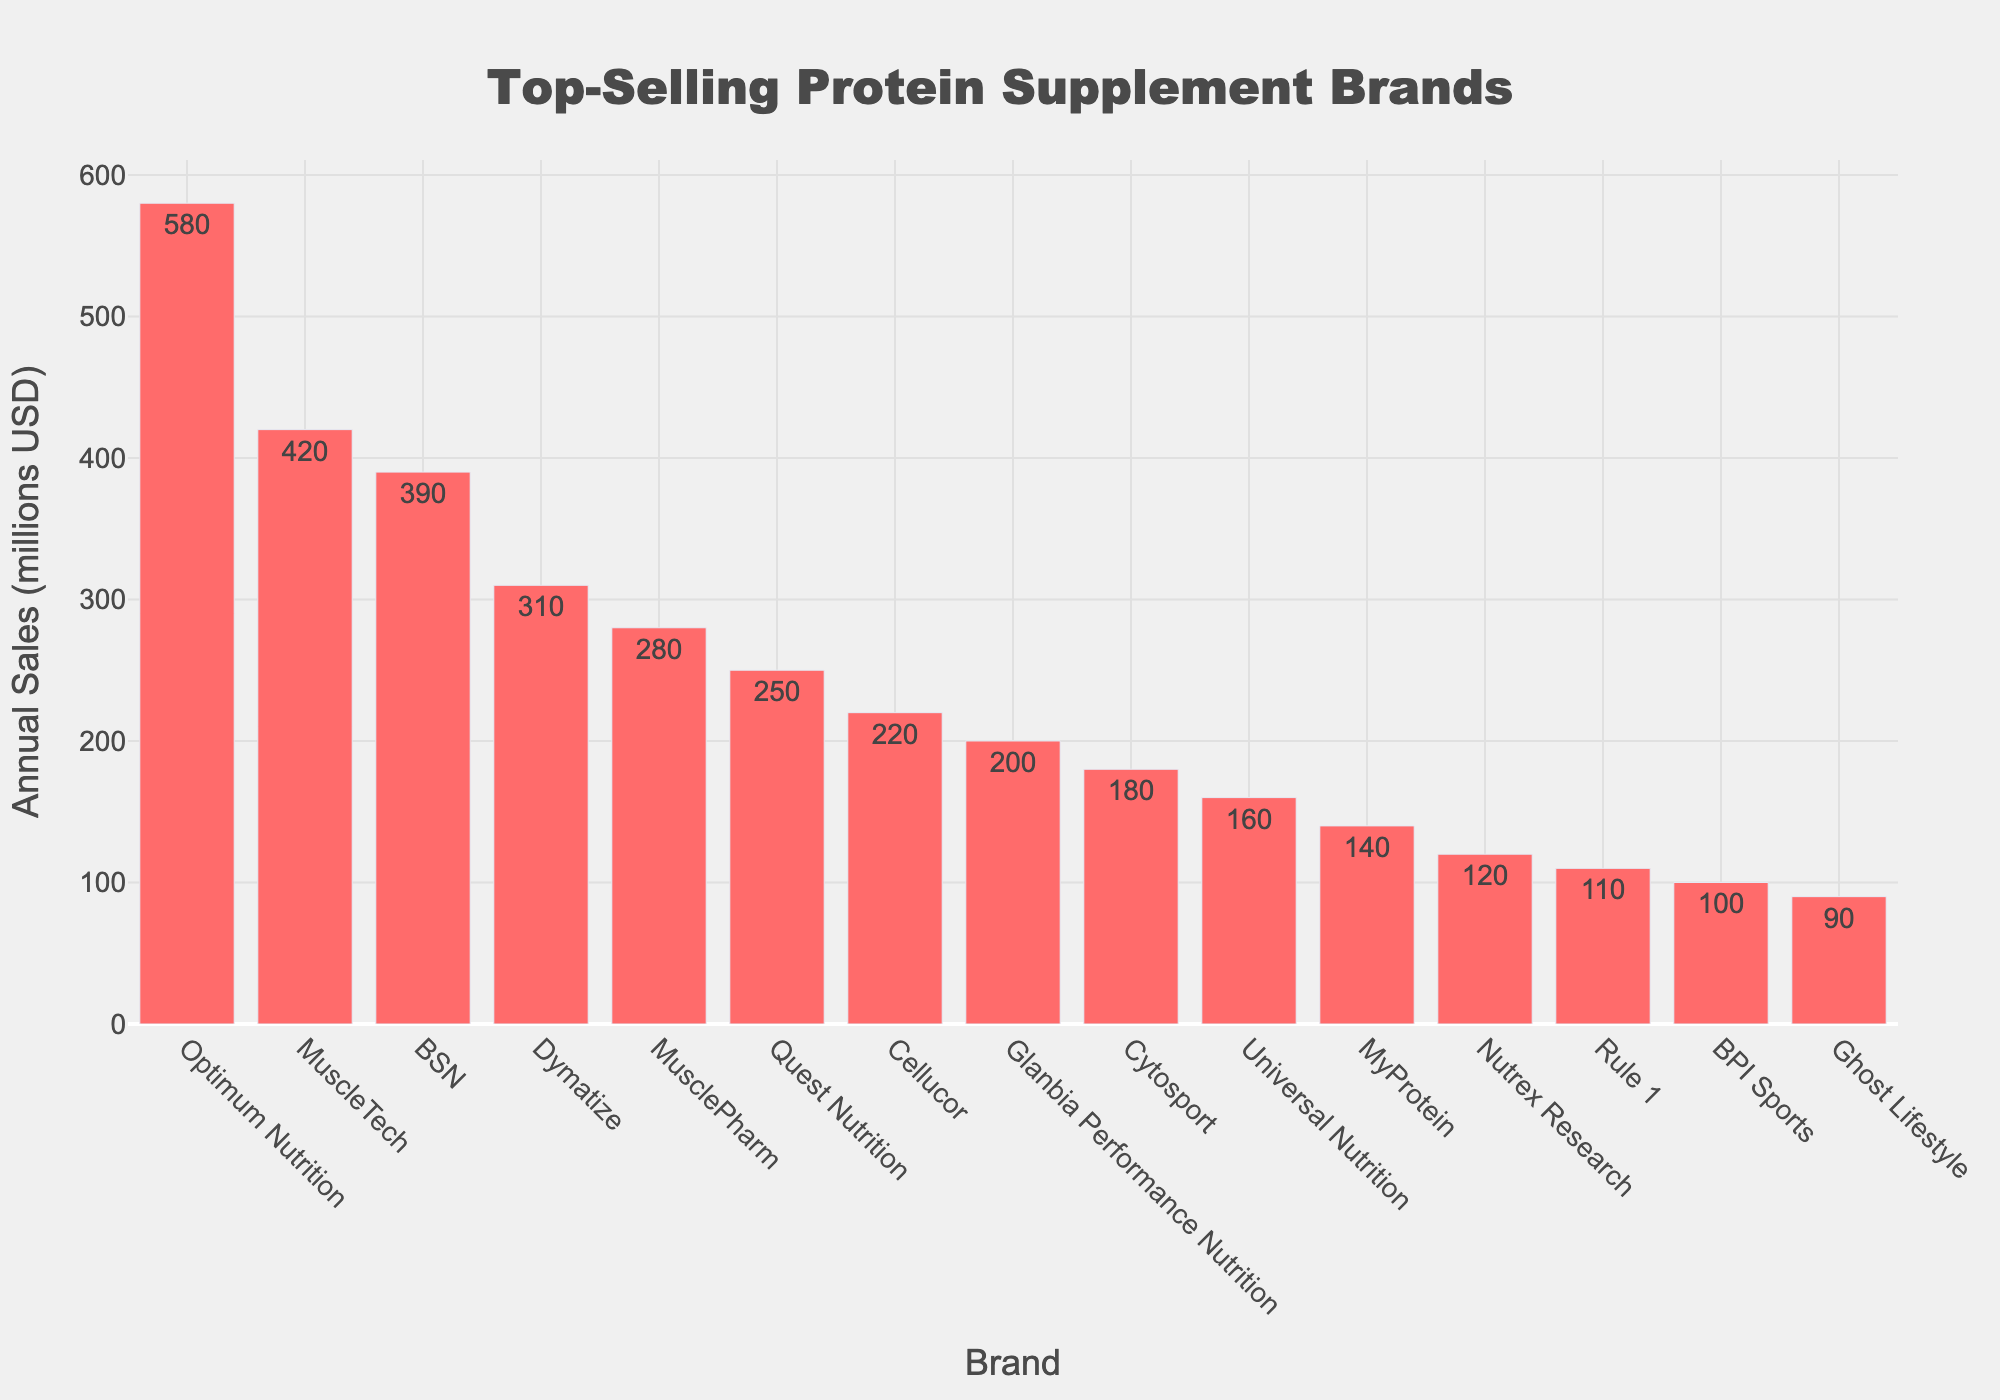what's the difference in annual sales between Optimum Nutrition and MuscleTech? Optimum Nutrition has annual sales of 580 million USD and MuscleTech has 420 million USD. The difference can be calculated by subtracting the sales of MuscleTech from Optimum Nutrition: 580 - 420 = 160
Answer: 160 which brand has the lowest annual sales? To find the brand with the lowest annual sales, look for the shortest bar in the chart. Ghost Lifestyle, with annual sales of 90 million USD, has the lowest sales
Answer: Ghost Lifestyle is the average annual sales of the top three brands greater than 400 million USD? The top three brands are Optimum Nutrition (580 million USD), MuscleTech (420 million USD), and BSN (390 million USD). The average is calculated as (580 + 420 + 390) / 3 = 1390 / 3 = 463.33, which is greater than 400
Answer: Yes how many brands have annual sales greater than 300 million USD? The brands with sales greater than 300 million USD are Optimum Nutrition (580 million USD), MuscleTech (420 million USD), BSN (390 million USD), and Dymatize (310 million USD). Counting these, we get 4 brands
Answer: 4 which brands have sales within the range of 100 to 200 million USD? Inspect the bars that fall within the height range correlating to 100 and 200 million USD. The brands fitting this range are Glanbia Performance Nutrition (200 million USD), Cytosport (180 million USD), Universal Nutrition (160 million USD), MyProtein (140 million USD), and Nutrex Research (120 million USD)
Answer: Glanbia Performance Nutrition, Cytosport, Universal Nutrition, MyProtein, Nutrex Research what's the percentage contribution of Quest Nutrition to the total sales of all brands? To find the percentage, divide sales of Quest Nutrition by the total sales of all brands and multiply by 100. Total sales = 580+420+390+310+280+250+220+200+180+160+140+120+110+100+90 = 3550. The percentage = (250 / 3550) * 100 ≈ 7.04%
Answer: 7.04% do Cellucor and Cytosport together have higher sales than MuscleTech alone? Cellucor has 220 million USD and Cytosport has 180 million USD. Combined, their sales are 220 + 180 = 400 million USD, which is less than MuscleTech's 420 million USD
Answer: No compare the sales of the top two brands combined with the combined sales of the bottom four brands Top two brands are Optimum Nutrition (580 million USD) and MuscleTech (420 million USD). Combined, their sales are 580 + 420 = 1000 million USD. Bottom four brands are Universal Nutrition (160 million USD), MyProtein (140 million USD), Nutrex Research (120 million USD), and Ghost Lifestyle (90 million USD). Combined, they are 160 + 140 + 120 + 90 = 510 million USD. Therefore, the top two brands have higher combined sales
Answer: Top two brands have higher combined sales how much more does Dymatize make than MusclePharm? Dymatize has annual sales of 310 million USD, and MusclePharm has 280 million USD. The difference is calculated as 310 - 280 = 30
Answer: 30 